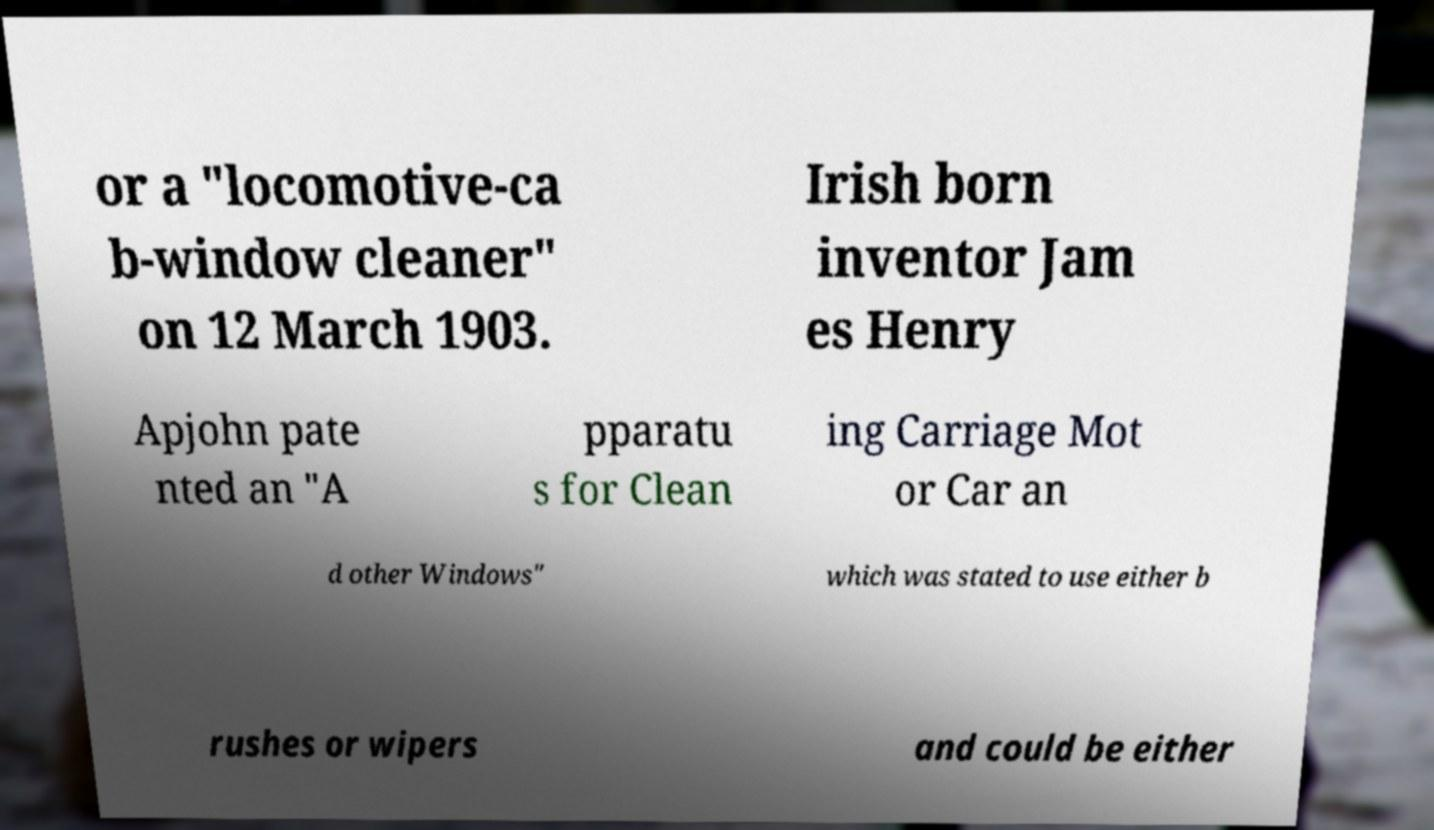Please identify and transcribe the text found in this image. or a "locomotive-ca b-window cleaner" on 12 March 1903. Irish born inventor Jam es Henry Apjohn pate nted an "A pparatu s for Clean ing Carriage Mot or Car an d other Windows" which was stated to use either b rushes or wipers and could be either 